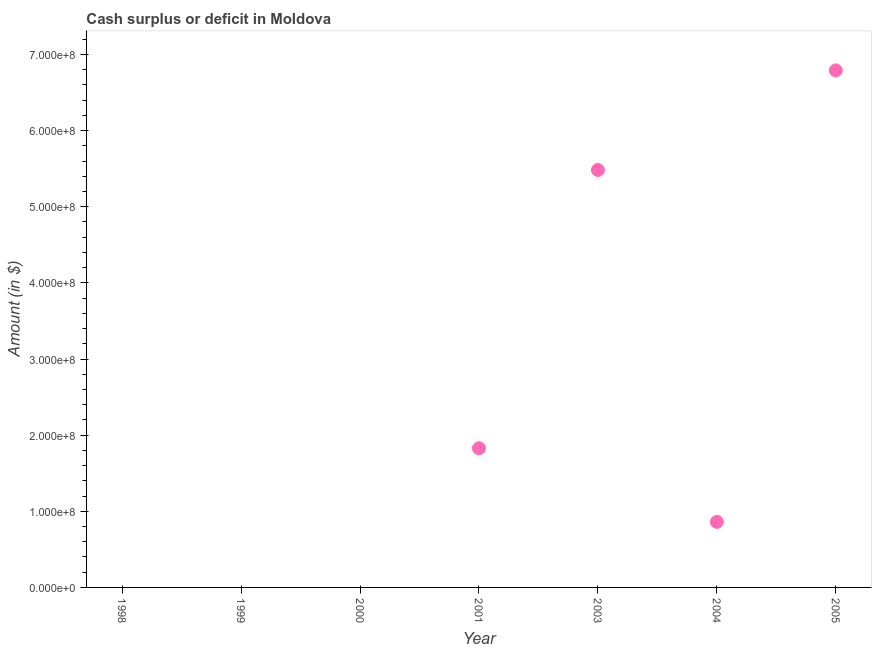What is the cash surplus or deficit in 2001?
Provide a short and direct response. 1.83e+08. Across all years, what is the maximum cash surplus or deficit?
Ensure brevity in your answer.  6.79e+08. In which year was the cash surplus or deficit maximum?
Your response must be concise. 2005. What is the sum of the cash surplus or deficit?
Ensure brevity in your answer.  1.50e+09. What is the difference between the cash surplus or deficit in 2001 and 2003?
Provide a succinct answer. -3.66e+08. What is the average cash surplus or deficit per year?
Your answer should be very brief. 2.14e+08. What is the median cash surplus or deficit?
Your response must be concise. 8.61e+07. What is the ratio of the cash surplus or deficit in 2001 to that in 2003?
Offer a terse response. 0.33. What is the difference between the highest and the second highest cash surplus or deficit?
Your answer should be compact. 1.31e+08. What is the difference between the highest and the lowest cash surplus or deficit?
Your answer should be compact. 6.79e+08. In how many years, is the cash surplus or deficit greater than the average cash surplus or deficit taken over all years?
Your response must be concise. 2. How many dotlines are there?
Offer a terse response. 1. How many years are there in the graph?
Your answer should be compact. 7. What is the difference between two consecutive major ticks on the Y-axis?
Your answer should be compact. 1.00e+08. Are the values on the major ticks of Y-axis written in scientific E-notation?
Your answer should be very brief. Yes. Does the graph contain any zero values?
Your response must be concise. Yes. What is the title of the graph?
Ensure brevity in your answer.  Cash surplus or deficit in Moldova. What is the label or title of the X-axis?
Offer a very short reply. Year. What is the label or title of the Y-axis?
Ensure brevity in your answer.  Amount (in $). What is the Amount (in $) in 1998?
Provide a succinct answer. 0. What is the Amount (in $) in 2000?
Provide a succinct answer. 0. What is the Amount (in $) in 2001?
Offer a very short reply. 1.83e+08. What is the Amount (in $) in 2003?
Your response must be concise. 5.48e+08. What is the Amount (in $) in 2004?
Ensure brevity in your answer.  8.61e+07. What is the Amount (in $) in 2005?
Your answer should be very brief. 6.79e+08. What is the difference between the Amount (in $) in 2001 and 2003?
Your answer should be very brief. -3.66e+08. What is the difference between the Amount (in $) in 2001 and 2004?
Offer a terse response. 9.67e+07. What is the difference between the Amount (in $) in 2001 and 2005?
Your answer should be compact. -4.96e+08. What is the difference between the Amount (in $) in 2003 and 2004?
Provide a succinct answer. 4.62e+08. What is the difference between the Amount (in $) in 2003 and 2005?
Your answer should be compact. -1.31e+08. What is the difference between the Amount (in $) in 2004 and 2005?
Keep it short and to the point. -5.93e+08. What is the ratio of the Amount (in $) in 2001 to that in 2003?
Give a very brief answer. 0.33. What is the ratio of the Amount (in $) in 2001 to that in 2004?
Give a very brief answer. 2.12. What is the ratio of the Amount (in $) in 2001 to that in 2005?
Keep it short and to the point. 0.27. What is the ratio of the Amount (in $) in 2003 to that in 2004?
Offer a very short reply. 6.37. What is the ratio of the Amount (in $) in 2003 to that in 2005?
Provide a succinct answer. 0.81. What is the ratio of the Amount (in $) in 2004 to that in 2005?
Your answer should be very brief. 0.13. 